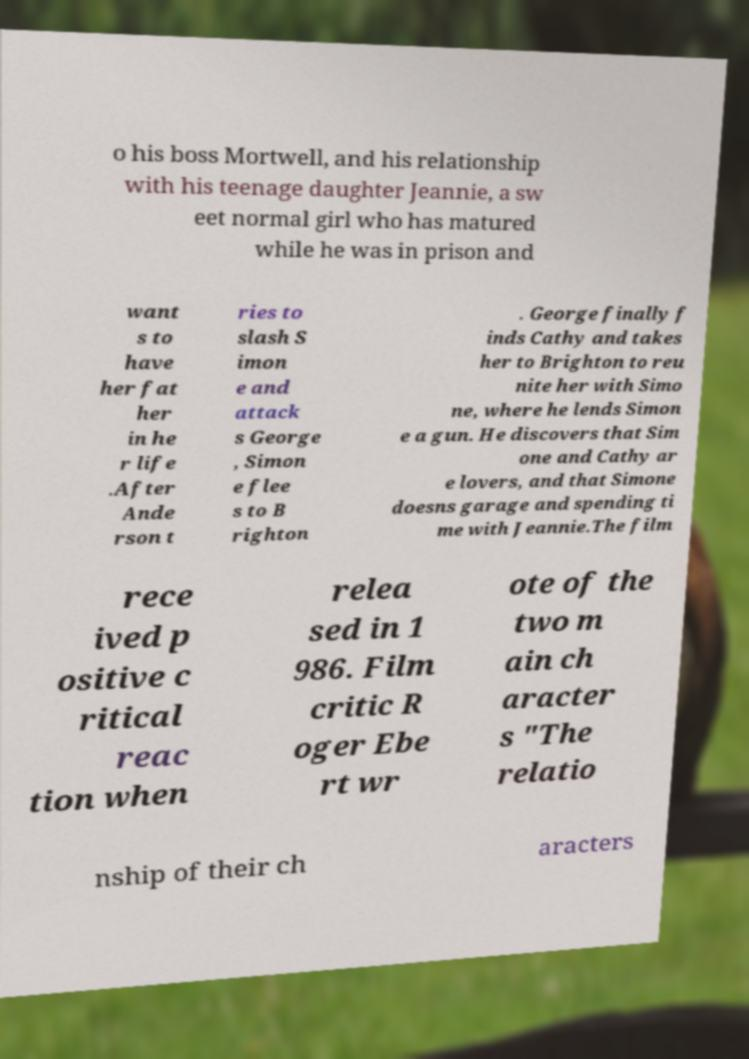There's text embedded in this image that I need extracted. Can you transcribe it verbatim? o his boss Mortwell, and his relationship with his teenage daughter Jeannie, a sw eet normal girl who has matured while he was in prison and want s to have her fat her in he r life .After Ande rson t ries to slash S imon e and attack s George , Simon e flee s to B righton . George finally f inds Cathy and takes her to Brighton to reu nite her with Simo ne, where he lends Simon e a gun. He discovers that Sim one and Cathy ar e lovers, and that Simone doesns garage and spending ti me with Jeannie.The film rece ived p ositive c ritical reac tion when relea sed in 1 986. Film critic R oger Ebe rt wr ote of the two m ain ch aracter s "The relatio nship of their ch aracters 